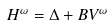<formula> <loc_0><loc_0><loc_500><loc_500>H ^ { \omega } = \Delta + B V ^ { \omega }</formula> 